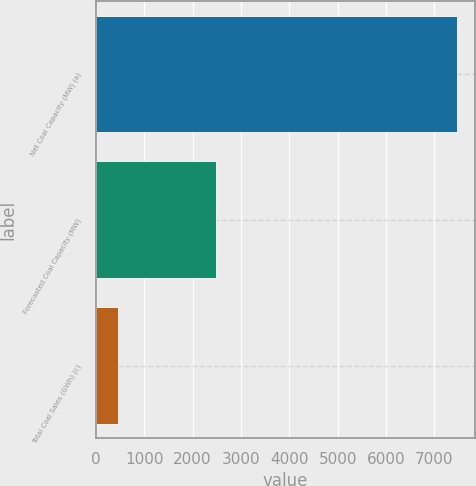Convert chart. <chart><loc_0><loc_0><loc_500><loc_500><bar_chart><fcel>Net Coal Capacity (MW) (a)<fcel>Forecasted Coal Capacity (MW)<fcel>Total Coal Sales (GWh) (c)<nl><fcel>7465<fcel>2483<fcel>455<nl></chart> 